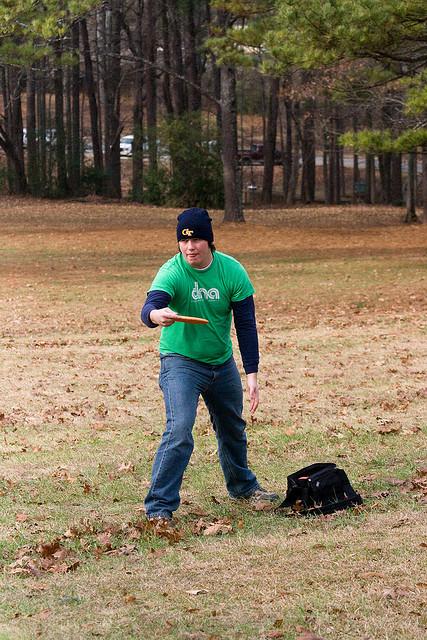What is the man holding?
Write a very short answer. Frisbee. What is in the man's hand?
Concise answer only. Frisbee. What color is the man's shirt?
Keep it brief. Green. Where is the person he is throwing to?
Keep it brief. In front of him. What is this person going to throw?
Give a very brief answer. Frisbee. What is the job of the man standing to the far left in the picture?
Quick response, please. Frisbee thrower. What is in the bag?
Write a very short answer. Frisbee. 